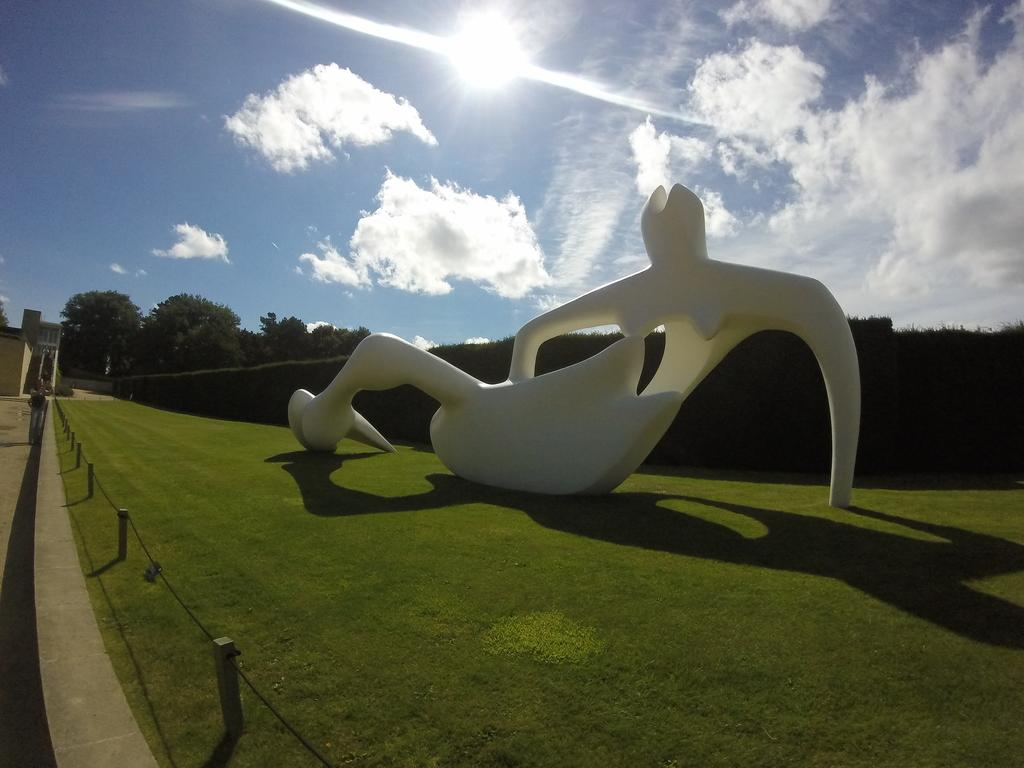What is the color of the object placed on the ground in the image? The object is white in color. Can you describe the surface on which the object is placed? The object is placed on the ground, which has grass. What can be seen in the background of the image? There are trees and the sky visible in the background of the image. What is the condition of the sky in the image? The sky has clouds and the sun is visible. How many bags are being used for transport in the image? There is no mention of bags or transportation in the image; it features a white object placed on grass with trees and a sky in the background. 